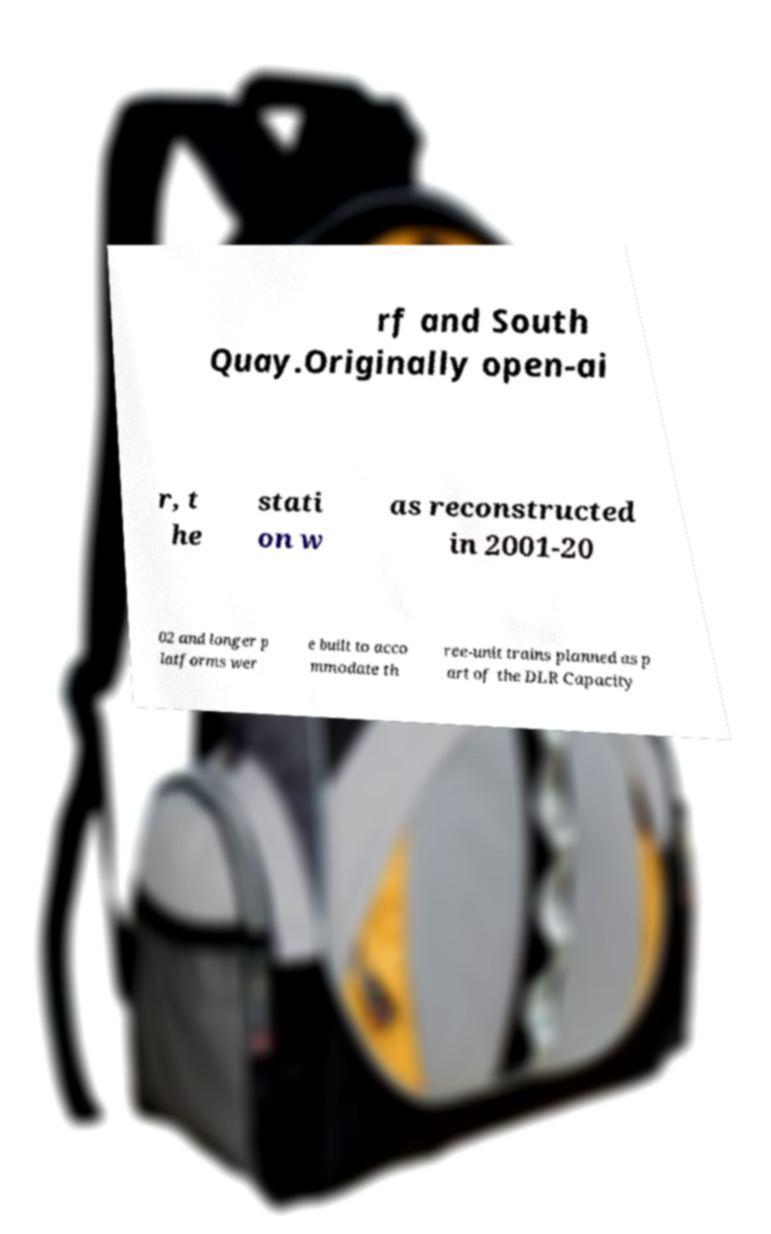There's text embedded in this image that I need extracted. Can you transcribe it verbatim? rf and South Quay.Originally open-ai r, t he stati on w as reconstructed in 2001-20 02 and longer p latforms wer e built to acco mmodate th ree-unit trains planned as p art of the DLR Capacity 